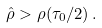<formula> <loc_0><loc_0><loc_500><loc_500>\hat { \rho } > \rho ( \tau _ { 0 } / 2 ) \, .</formula> 